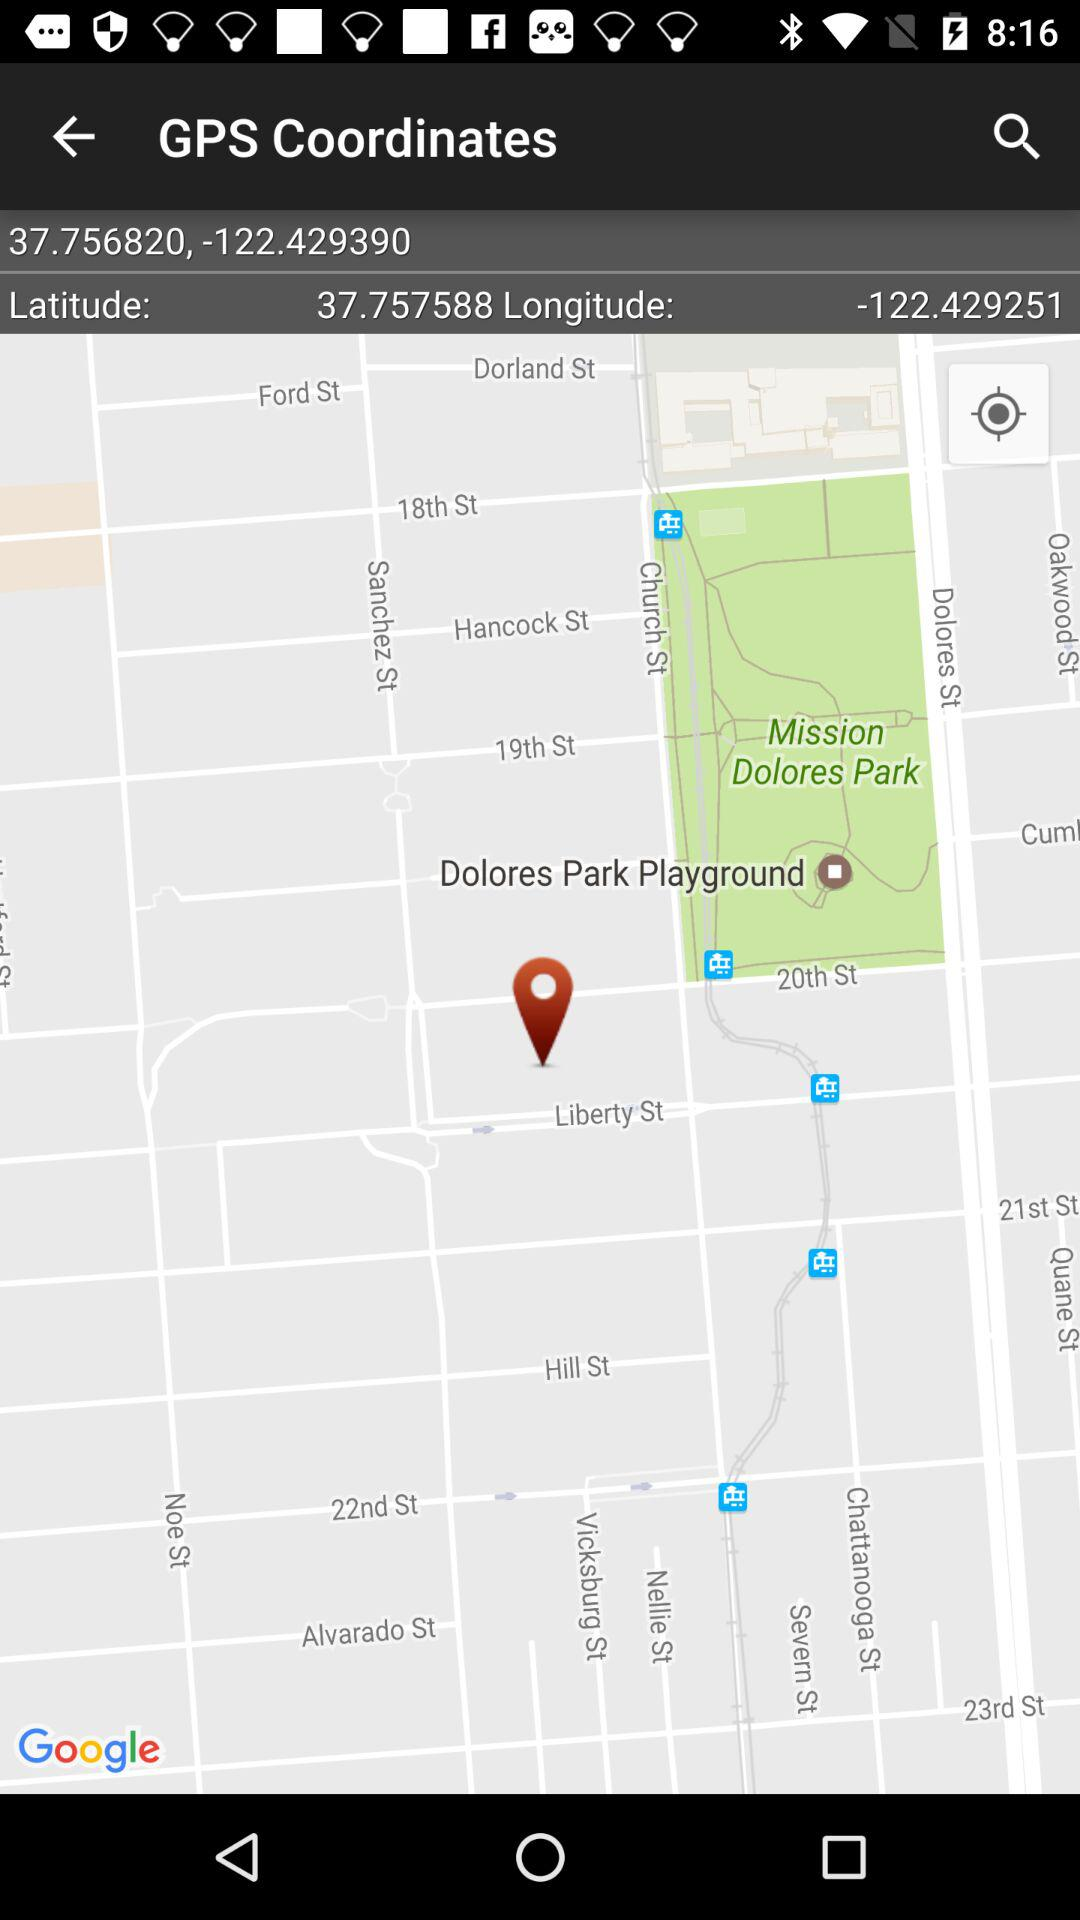What is the latitude value? The latitude value is 37.757588. 